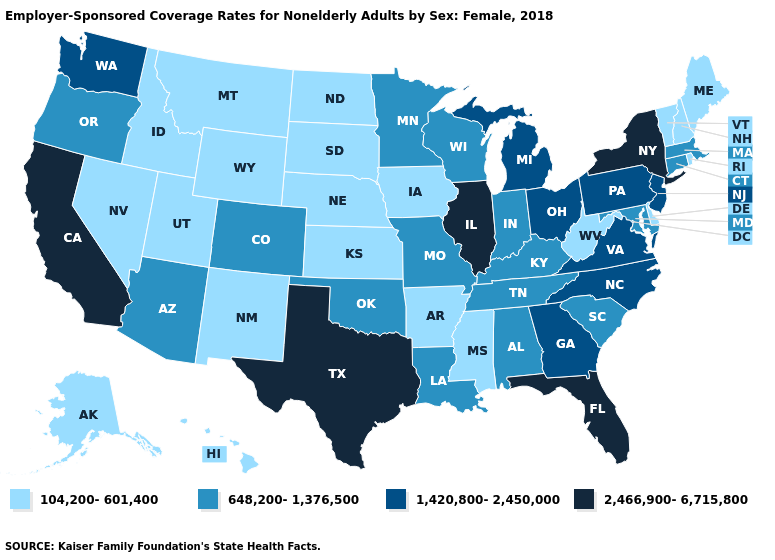What is the value of Washington?
Be succinct. 1,420,800-2,450,000. Name the states that have a value in the range 648,200-1,376,500?
Keep it brief. Alabama, Arizona, Colorado, Connecticut, Indiana, Kentucky, Louisiana, Maryland, Massachusetts, Minnesota, Missouri, Oklahoma, Oregon, South Carolina, Tennessee, Wisconsin. What is the highest value in the USA?
Be succinct. 2,466,900-6,715,800. What is the value of Maryland?
Short answer required. 648,200-1,376,500. What is the lowest value in states that border South Dakota?
Keep it brief. 104,200-601,400. What is the value of West Virginia?
Concise answer only. 104,200-601,400. What is the value of Mississippi?
Answer briefly. 104,200-601,400. Does New Mexico have the lowest value in the USA?
Answer briefly. Yes. What is the value of Texas?
Give a very brief answer. 2,466,900-6,715,800. What is the value of Georgia?
Short answer required. 1,420,800-2,450,000. Name the states that have a value in the range 648,200-1,376,500?
Short answer required. Alabama, Arizona, Colorado, Connecticut, Indiana, Kentucky, Louisiana, Maryland, Massachusetts, Minnesota, Missouri, Oklahoma, Oregon, South Carolina, Tennessee, Wisconsin. Does the first symbol in the legend represent the smallest category?
Short answer required. Yes. How many symbols are there in the legend?
Quick response, please. 4. Which states hav the highest value in the MidWest?
Concise answer only. Illinois. What is the highest value in the Northeast ?
Short answer required. 2,466,900-6,715,800. 